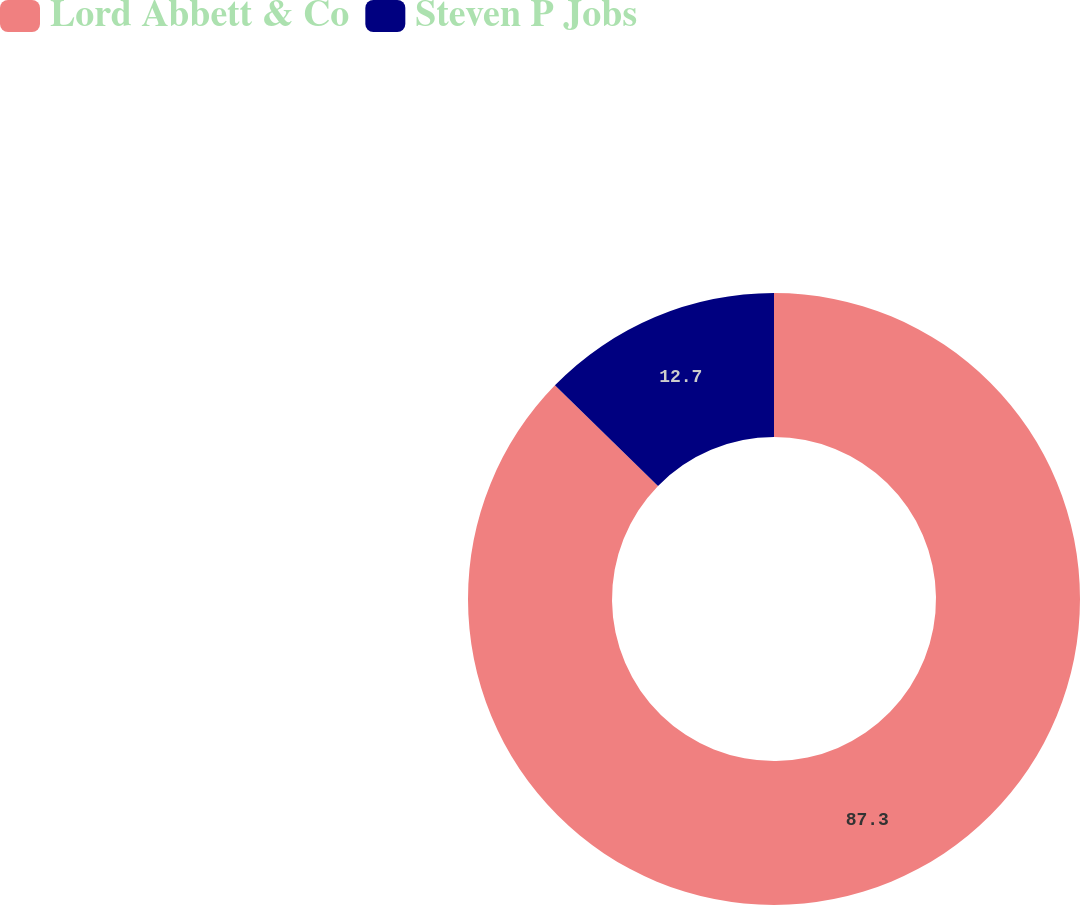<chart> <loc_0><loc_0><loc_500><loc_500><pie_chart><fcel>Lord Abbett & Co<fcel>Steven P Jobs<nl><fcel>87.3%<fcel>12.7%<nl></chart> 